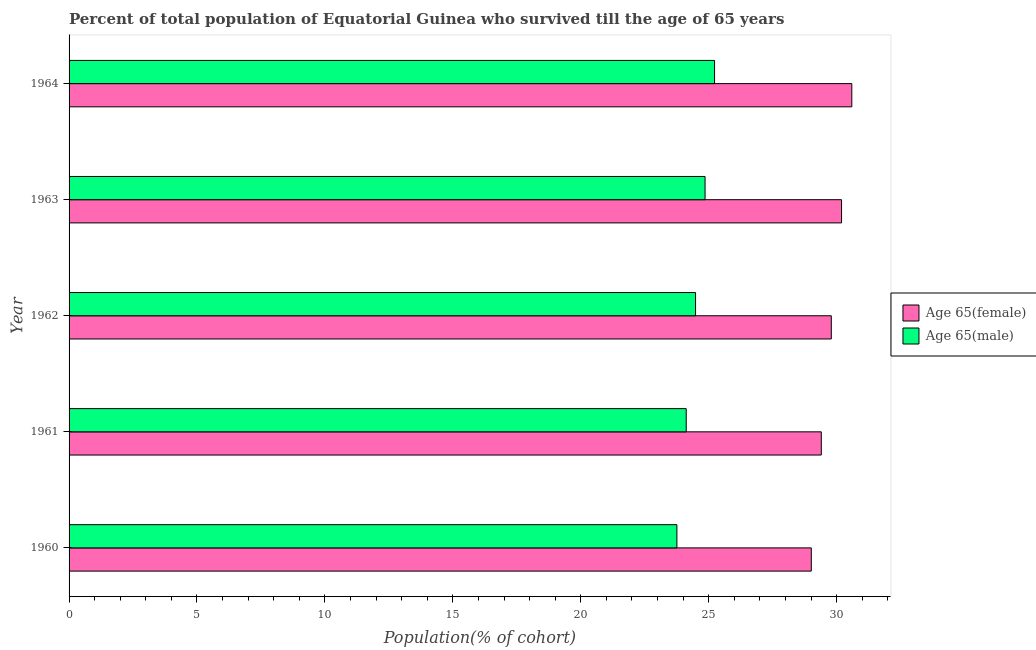In how many cases, is the number of bars for a given year not equal to the number of legend labels?
Offer a very short reply. 0. What is the percentage of male population who survived till age of 65 in 1964?
Make the answer very short. 25.23. Across all years, what is the maximum percentage of male population who survived till age of 65?
Offer a terse response. 25.23. Across all years, what is the minimum percentage of female population who survived till age of 65?
Ensure brevity in your answer.  29.01. In which year was the percentage of male population who survived till age of 65 maximum?
Offer a very short reply. 1964. In which year was the percentage of male population who survived till age of 65 minimum?
Provide a short and direct response. 1960. What is the total percentage of female population who survived till age of 65 in the graph?
Your answer should be compact. 149. What is the difference between the percentage of female population who survived till age of 65 in 1961 and that in 1963?
Provide a succinct answer. -0.79. What is the difference between the percentage of female population who survived till age of 65 in 1961 and the percentage of male population who survived till age of 65 in 1963?
Offer a very short reply. 4.54. What is the average percentage of female population who survived till age of 65 per year?
Ensure brevity in your answer.  29.8. In the year 1960, what is the difference between the percentage of female population who survived till age of 65 and percentage of male population who survived till age of 65?
Provide a short and direct response. 5.25. In how many years, is the percentage of female population who survived till age of 65 greater than 25 %?
Ensure brevity in your answer.  5. What is the difference between the highest and the second highest percentage of female population who survived till age of 65?
Give a very brief answer. 0.4. What is the difference between the highest and the lowest percentage of male population who survived till age of 65?
Keep it short and to the point. 1.47. Is the sum of the percentage of male population who survived till age of 65 in 1961 and 1964 greater than the maximum percentage of female population who survived till age of 65 across all years?
Provide a succinct answer. Yes. What does the 1st bar from the top in 1960 represents?
Give a very brief answer. Age 65(male). What does the 1st bar from the bottom in 1960 represents?
Your response must be concise. Age 65(female). How many bars are there?
Your answer should be compact. 10. Are all the bars in the graph horizontal?
Keep it short and to the point. Yes. How many years are there in the graph?
Your response must be concise. 5. What is the difference between two consecutive major ticks on the X-axis?
Keep it short and to the point. 5. Does the graph contain any zero values?
Provide a succinct answer. No. Does the graph contain grids?
Ensure brevity in your answer.  No. Where does the legend appear in the graph?
Give a very brief answer. Center right. How many legend labels are there?
Your answer should be compact. 2. How are the legend labels stacked?
Give a very brief answer. Vertical. What is the title of the graph?
Provide a short and direct response. Percent of total population of Equatorial Guinea who survived till the age of 65 years. What is the label or title of the X-axis?
Your answer should be very brief. Population(% of cohort). What is the label or title of the Y-axis?
Offer a terse response. Year. What is the Population(% of cohort) in Age 65(female) in 1960?
Offer a very short reply. 29.01. What is the Population(% of cohort) of Age 65(male) in 1960?
Your answer should be compact. 23.76. What is the Population(% of cohort) of Age 65(female) in 1961?
Offer a terse response. 29.4. What is the Population(% of cohort) in Age 65(male) in 1961?
Give a very brief answer. 24.12. What is the Population(% of cohort) in Age 65(female) in 1962?
Provide a short and direct response. 29.79. What is the Population(% of cohort) of Age 65(male) in 1962?
Offer a very short reply. 24.49. What is the Population(% of cohort) of Age 65(female) in 1963?
Your answer should be compact. 30.19. What is the Population(% of cohort) in Age 65(male) in 1963?
Provide a short and direct response. 24.86. What is the Population(% of cohort) in Age 65(female) in 1964?
Give a very brief answer. 30.59. What is the Population(% of cohort) of Age 65(male) in 1964?
Your answer should be compact. 25.23. Across all years, what is the maximum Population(% of cohort) in Age 65(female)?
Provide a succinct answer. 30.59. Across all years, what is the maximum Population(% of cohort) in Age 65(male)?
Make the answer very short. 25.23. Across all years, what is the minimum Population(% of cohort) in Age 65(female)?
Your answer should be very brief. 29.01. Across all years, what is the minimum Population(% of cohort) in Age 65(male)?
Ensure brevity in your answer.  23.76. What is the total Population(% of cohort) of Age 65(female) in the graph?
Your answer should be very brief. 149. What is the total Population(% of cohort) in Age 65(male) in the graph?
Make the answer very short. 122.46. What is the difference between the Population(% of cohort) of Age 65(female) in 1960 and that in 1961?
Offer a very short reply. -0.39. What is the difference between the Population(% of cohort) of Age 65(male) in 1960 and that in 1961?
Provide a short and direct response. -0.36. What is the difference between the Population(% of cohort) in Age 65(female) in 1960 and that in 1962?
Provide a succinct answer. -0.78. What is the difference between the Population(% of cohort) in Age 65(male) in 1960 and that in 1962?
Your response must be concise. -0.73. What is the difference between the Population(% of cohort) of Age 65(female) in 1960 and that in 1963?
Offer a terse response. -1.18. What is the difference between the Population(% of cohort) of Age 65(male) in 1960 and that in 1963?
Provide a succinct answer. -1.1. What is the difference between the Population(% of cohort) of Age 65(female) in 1960 and that in 1964?
Your answer should be compact. -1.58. What is the difference between the Population(% of cohort) of Age 65(male) in 1960 and that in 1964?
Provide a short and direct response. -1.47. What is the difference between the Population(% of cohort) in Age 65(female) in 1961 and that in 1962?
Ensure brevity in your answer.  -0.39. What is the difference between the Population(% of cohort) in Age 65(male) in 1961 and that in 1962?
Keep it short and to the point. -0.36. What is the difference between the Population(% of cohort) of Age 65(female) in 1961 and that in 1963?
Provide a succinct answer. -0.79. What is the difference between the Population(% of cohort) of Age 65(male) in 1961 and that in 1963?
Make the answer very short. -0.74. What is the difference between the Population(% of cohort) in Age 65(female) in 1961 and that in 1964?
Your answer should be compact. -1.19. What is the difference between the Population(% of cohort) of Age 65(male) in 1961 and that in 1964?
Give a very brief answer. -1.11. What is the difference between the Population(% of cohort) in Age 65(female) in 1962 and that in 1963?
Make the answer very short. -0.4. What is the difference between the Population(% of cohort) in Age 65(male) in 1962 and that in 1963?
Offer a very short reply. -0.37. What is the difference between the Population(% of cohort) of Age 65(female) in 1962 and that in 1964?
Offer a terse response. -0.8. What is the difference between the Population(% of cohort) in Age 65(male) in 1962 and that in 1964?
Offer a terse response. -0.74. What is the difference between the Population(% of cohort) of Age 65(female) in 1963 and that in 1964?
Offer a very short reply. -0.4. What is the difference between the Population(% of cohort) in Age 65(male) in 1963 and that in 1964?
Make the answer very short. -0.37. What is the difference between the Population(% of cohort) in Age 65(female) in 1960 and the Population(% of cohort) in Age 65(male) in 1961?
Your answer should be very brief. 4.89. What is the difference between the Population(% of cohort) of Age 65(female) in 1960 and the Population(% of cohort) of Age 65(male) in 1962?
Offer a very short reply. 4.52. What is the difference between the Population(% of cohort) of Age 65(female) in 1960 and the Population(% of cohort) of Age 65(male) in 1963?
Provide a succinct answer. 4.15. What is the difference between the Population(% of cohort) in Age 65(female) in 1960 and the Population(% of cohort) in Age 65(male) in 1964?
Make the answer very short. 3.78. What is the difference between the Population(% of cohort) of Age 65(female) in 1961 and the Population(% of cohort) of Age 65(male) in 1962?
Provide a succinct answer. 4.91. What is the difference between the Population(% of cohort) of Age 65(female) in 1961 and the Population(% of cohort) of Age 65(male) in 1963?
Ensure brevity in your answer.  4.54. What is the difference between the Population(% of cohort) in Age 65(female) in 1961 and the Population(% of cohort) in Age 65(male) in 1964?
Offer a very short reply. 4.17. What is the difference between the Population(% of cohort) of Age 65(female) in 1962 and the Population(% of cohort) of Age 65(male) in 1963?
Ensure brevity in your answer.  4.93. What is the difference between the Population(% of cohort) in Age 65(female) in 1962 and the Population(% of cohort) in Age 65(male) in 1964?
Give a very brief answer. 4.56. What is the difference between the Population(% of cohort) of Age 65(female) in 1963 and the Population(% of cohort) of Age 65(male) in 1964?
Your answer should be very brief. 4.96. What is the average Population(% of cohort) of Age 65(female) per year?
Give a very brief answer. 29.8. What is the average Population(% of cohort) of Age 65(male) per year?
Your answer should be very brief. 24.49. In the year 1960, what is the difference between the Population(% of cohort) of Age 65(female) and Population(% of cohort) of Age 65(male)?
Provide a short and direct response. 5.25. In the year 1961, what is the difference between the Population(% of cohort) in Age 65(female) and Population(% of cohort) in Age 65(male)?
Ensure brevity in your answer.  5.28. In the year 1962, what is the difference between the Population(% of cohort) of Age 65(female) and Population(% of cohort) of Age 65(male)?
Keep it short and to the point. 5.31. In the year 1963, what is the difference between the Population(% of cohort) of Age 65(female) and Population(% of cohort) of Age 65(male)?
Your answer should be very brief. 5.34. In the year 1964, what is the difference between the Population(% of cohort) in Age 65(female) and Population(% of cohort) in Age 65(male)?
Keep it short and to the point. 5.36. What is the ratio of the Population(% of cohort) of Age 65(female) in 1960 to that in 1961?
Your answer should be very brief. 0.99. What is the ratio of the Population(% of cohort) in Age 65(male) in 1960 to that in 1961?
Provide a short and direct response. 0.98. What is the ratio of the Population(% of cohort) of Age 65(female) in 1960 to that in 1962?
Provide a short and direct response. 0.97. What is the ratio of the Population(% of cohort) of Age 65(male) in 1960 to that in 1962?
Provide a short and direct response. 0.97. What is the ratio of the Population(% of cohort) in Age 65(female) in 1960 to that in 1963?
Your response must be concise. 0.96. What is the ratio of the Population(% of cohort) of Age 65(male) in 1960 to that in 1963?
Provide a succinct answer. 0.96. What is the ratio of the Population(% of cohort) in Age 65(female) in 1960 to that in 1964?
Keep it short and to the point. 0.95. What is the ratio of the Population(% of cohort) in Age 65(male) in 1960 to that in 1964?
Provide a short and direct response. 0.94. What is the ratio of the Population(% of cohort) in Age 65(female) in 1961 to that in 1962?
Provide a succinct answer. 0.99. What is the ratio of the Population(% of cohort) in Age 65(male) in 1961 to that in 1962?
Give a very brief answer. 0.99. What is the ratio of the Population(% of cohort) of Age 65(female) in 1961 to that in 1963?
Your answer should be compact. 0.97. What is the ratio of the Population(% of cohort) of Age 65(male) in 1961 to that in 1963?
Make the answer very short. 0.97. What is the ratio of the Population(% of cohort) of Age 65(female) in 1961 to that in 1964?
Offer a terse response. 0.96. What is the ratio of the Population(% of cohort) of Age 65(male) in 1961 to that in 1964?
Your answer should be compact. 0.96. What is the ratio of the Population(% of cohort) in Age 65(female) in 1962 to that in 1963?
Your response must be concise. 0.99. What is the ratio of the Population(% of cohort) of Age 65(male) in 1962 to that in 1963?
Give a very brief answer. 0.99. What is the ratio of the Population(% of cohort) in Age 65(female) in 1962 to that in 1964?
Offer a very short reply. 0.97. What is the ratio of the Population(% of cohort) of Age 65(male) in 1962 to that in 1964?
Ensure brevity in your answer.  0.97. What is the ratio of the Population(% of cohort) of Age 65(female) in 1963 to that in 1964?
Your answer should be compact. 0.99. What is the difference between the highest and the second highest Population(% of cohort) of Age 65(female)?
Keep it short and to the point. 0.4. What is the difference between the highest and the second highest Population(% of cohort) in Age 65(male)?
Provide a succinct answer. 0.37. What is the difference between the highest and the lowest Population(% of cohort) in Age 65(female)?
Ensure brevity in your answer.  1.58. What is the difference between the highest and the lowest Population(% of cohort) of Age 65(male)?
Provide a short and direct response. 1.47. 